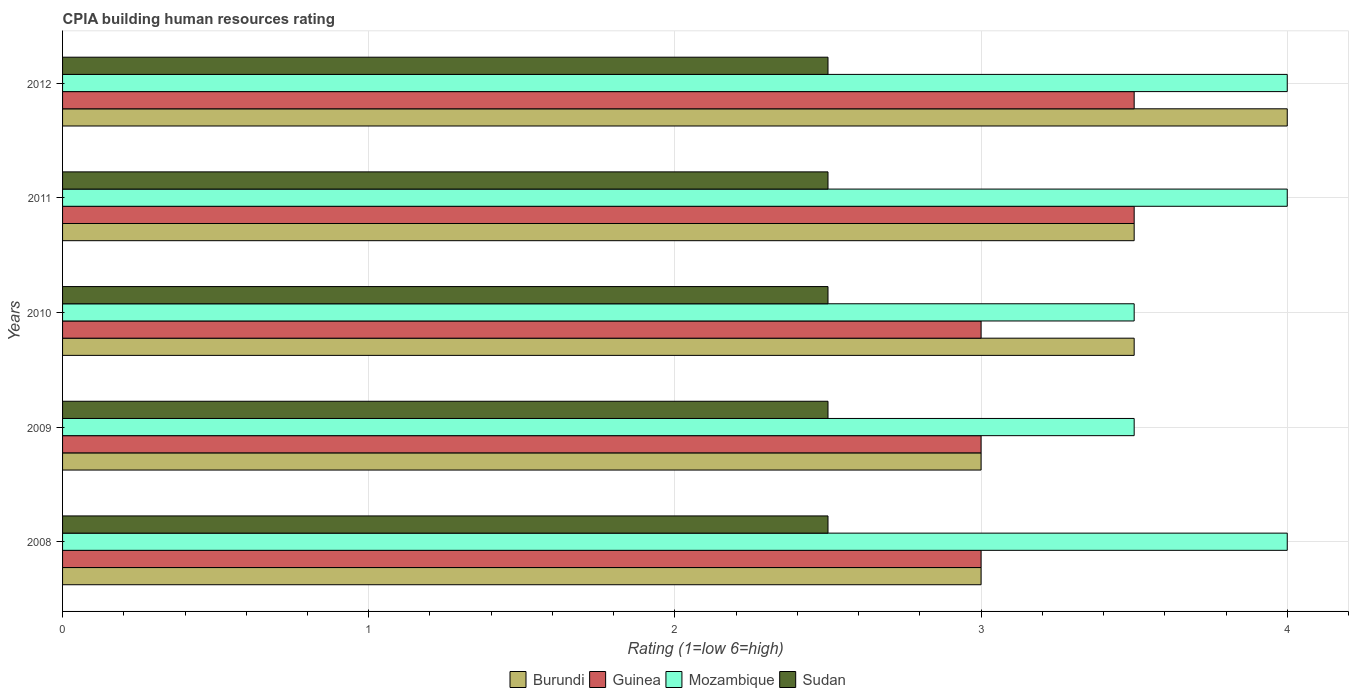Are the number of bars on each tick of the Y-axis equal?
Give a very brief answer. Yes. Across all years, what is the maximum CPIA rating in Guinea?
Offer a terse response. 3.5. What is the total CPIA rating in Sudan in the graph?
Give a very brief answer. 12.5. What is the difference between the CPIA rating in Sudan in 2011 and the CPIA rating in Guinea in 2012?
Offer a terse response. -1. In the year 2009, what is the difference between the CPIA rating in Sudan and CPIA rating in Guinea?
Your answer should be very brief. -0.5. In how many years, is the CPIA rating in Guinea greater than 2.4 ?
Your answer should be compact. 5. Is the difference between the CPIA rating in Sudan in 2008 and 2011 greater than the difference between the CPIA rating in Guinea in 2008 and 2011?
Ensure brevity in your answer.  Yes. What is the difference between the highest and the second highest CPIA rating in Guinea?
Give a very brief answer. 0. What is the difference between the highest and the lowest CPIA rating in Guinea?
Give a very brief answer. 0.5. What does the 4th bar from the top in 2010 represents?
Your answer should be compact. Burundi. What does the 3rd bar from the bottom in 2012 represents?
Provide a succinct answer. Mozambique. How many bars are there?
Keep it short and to the point. 20. Are all the bars in the graph horizontal?
Your answer should be very brief. Yes. What is the difference between two consecutive major ticks on the X-axis?
Provide a succinct answer. 1. Where does the legend appear in the graph?
Provide a short and direct response. Bottom center. How are the legend labels stacked?
Provide a succinct answer. Horizontal. What is the title of the graph?
Your answer should be compact. CPIA building human resources rating. Does "Croatia" appear as one of the legend labels in the graph?
Your response must be concise. No. What is the label or title of the X-axis?
Your response must be concise. Rating (1=low 6=high). What is the Rating (1=low 6=high) in Guinea in 2008?
Provide a short and direct response. 3. What is the Rating (1=low 6=high) in Sudan in 2008?
Your answer should be very brief. 2.5. What is the Rating (1=low 6=high) in Guinea in 2009?
Offer a terse response. 3. What is the Rating (1=low 6=high) of Mozambique in 2009?
Provide a succinct answer. 3.5. What is the Rating (1=low 6=high) of Guinea in 2010?
Your answer should be very brief. 3. What is the Rating (1=low 6=high) in Mozambique in 2010?
Make the answer very short. 3.5. What is the Rating (1=low 6=high) of Guinea in 2011?
Provide a succinct answer. 3.5. What is the Rating (1=low 6=high) in Mozambique in 2012?
Your answer should be very brief. 4. What is the Rating (1=low 6=high) of Sudan in 2012?
Your answer should be compact. 2.5. Across all years, what is the maximum Rating (1=low 6=high) of Burundi?
Keep it short and to the point. 4. Across all years, what is the minimum Rating (1=low 6=high) in Burundi?
Offer a very short reply. 3. Across all years, what is the minimum Rating (1=low 6=high) in Guinea?
Your response must be concise. 3. What is the total Rating (1=low 6=high) of Guinea in the graph?
Offer a very short reply. 16. What is the total Rating (1=low 6=high) of Sudan in the graph?
Provide a succinct answer. 12.5. What is the difference between the Rating (1=low 6=high) of Guinea in 2008 and that in 2009?
Make the answer very short. 0. What is the difference between the Rating (1=low 6=high) in Sudan in 2008 and that in 2009?
Offer a very short reply. 0. What is the difference between the Rating (1=low 6=high) in Burundi in 2008 and that in 2010?
Keep it short and to the point. -0.5. What is the difference between the Rating (1=low 6=high) of Mozambique in 2008 and that in 2010?
Offer a very short reply. 0.5. What is the difference between the Rating (1=low 6=high) in Guinea in 2008 and that in 2011?
Make the answer very short. -0.5. What is the difference between the Rating (1=low 6=high) of Mozambique in 2008 and that in 2011?
Provide a succinct answer. 0. What is the difference between the Rating (1=low 6=high) of Sudan in 2008 and that in 2011?
Give a very brief answer. 0. What is the difference between the Rating (1=low 6=high) in Burundi in 2008 and that in 2012?
Your response must be concise. -1. What is the difference between the Rating (1=low 6=high) of Guinea in 2008 and that in 2012?
Your response must be concise. -0.5. What is the difference between the Rating (1=low 6=high) in Sudan in 2008 and that in 2012?
Provide a short and direct response. 0. What is the difference between the Rating (1=low 6=high) of Mozambique in 2009 and that in 2010?
Keep it short and to the point. 0. What is the difference between the Rating (1=low 6=high) in Sudan in 2009 and that in 2010?
Provide a succinct answer. 0. What is the difference between the Rating (1=low 6=high) of Sudan in 2009 and that in 2011?
Give a very brief answer. 0. What is the difference between the Rating (1=low 6=high) in Guinea in 2009 and that in 2012?
Offer a very short reply. -0.5. What is the difference between the Rating (1=low 6=high) of Mozambique in 2009 and that in 2012?
Your answer should be very brief. -0.5. What is the difference between the Rating (1=low 6=high) in Sudan in 2009 and that in 2012?
Ensure brevity in your answer.  0. What is the difference between the Rating (1=low 6=high) in Guinea in 2010 and that in 2011?
Offer a terse response. -0.5. What is the difference between the Rating (1=low 6=high) in Mozambique in 2010 and that in 2011?
Make the answer very short. -0.5. What is the difference between the Rating (1=low 6=high) of Sudan in 2010 and that in 2011?
Ensure brevity in your answer.  0. What is the difference between the Rating (1=low 6=high) in Mozambique in 2010 and that in 2012?
Your answer should be compact. -0.5. What is the difference between the Rating (1=low 6=high) in Sudan in 2010 and that in 2012?
Make the answer very short. 0. What is the difference between the Rating (1=low 6=high) in Guinea in 2011 and that in 2012?
Ensure brevity in your answer.  0. What is the difference between the Rating (1=low 6=high) in Mozambique in 2011 and that in 2012?
Provide a succinct answer. 0. What is the difference between the Rating (1=low 6=high) in Sudan in 2011 and that in 2012?
Ensure brevity in your answer.  0. What is the difference between the Rating (1=low 6=high) of Burundi in 2008 and the Rating (1=low 6=high) of Mozambique in 2009?
Provide a short and direct response. -0.5. What is the difference between the Rating (1=low 6=high) of Guinea in 2008 and the Rating (1=low 6=high) of Mozambique in 2009?
Keep it short and to the point. -0.5. What is the difference between the Rating (1=low 6=high) in Burundi in 2008 and the Rating (1=low 6=high) in Guinea in 2010?
Provide a succinct answer. 0. What is the difference between the Rating (1=low 6=high) of Burundi in 2008 and the Rating (1=low 6=high) of Mozambique in 2010?
Offer a terse response. -0.5. What is the difference between the Rating (1=low 6=high) in Burundi in 2008 and the Rating (1=low 6=high) in Guinea in 2011?
Offer a very short reply. -0.5. What is the difference between the Rating (1=low 6=high) in Burundi in 2008 and the Rating (1=low 6=high) in Mozambique in 2011?
Ensure brevity in your answer.  -1. What is the difference between the Rating (1=low 6=high) in Guinea in 2008 and the Rating (1=low 6=high) in Mozambique in 2011?
Give a very brief answer. -1. What is the difference between the Rating (1=low 6=high) of Guinea in 2008 and the Rating (1=low 6=high) of Sudan in 2011?
Give a very brief answer. 0.5. What is the difference between the Rating (1=low 6=high) of Mozambique in 2008 and the Rating (1=low 6=high) of Sudan in 2011?
Your response must be concise. 1.5. What is the difference between the Rating (1=low 6=high) of Burundi in 2008 and the Rating (1=low 6=high) of Guinea in 2012?
Keep it short and to the point. -0.5. What is the difference between the Rating (1=low 6=high) in Burundi in 2008 and the Rating (1=low 6=high) in Sudan in 2012?
Your answer should be very brief. 0.5. What is the difference between the Rating (1=low 6=high) in Guinea in 2008 and the Rating (1=low 6=high) in Sudan in 2012?
Make the answer very short. 0.5. What is the difference between the Rating (1=low 6=high) of Burundi in 2009 and the Rating (1=low 6=high) of Guinea in 2010?
Your answer should be compact. 0. What is the difference between the Rating (1=low 6=high) in Burundi in 2009 and the Rating (1=low 6=high) in Mozambique in 2010?
Your answer should be very brief. -0.5. What is the difference between the Rating (1=low 6=high) in Burundi in 2009 and the Rating (1=low 6=high) in Sudan in 2010?
Offer a terse response. 0.5. What is the difference between the Rating (1=low 6=high) of Guinea in 2009 and the Rating (1=low 6=high) of Sudan in 2010?
Your answer should be compact. 0.5. What is the difference between the Rating (1=low 6=high) in Mozambique in 2009 and the Rating (1=low 6=high) in Sudan in 2010?
Provide a short and direct response. 1. What is the difference between the Rating (1=low 6=high) of Burundi in 2009 and the Rating (1=low 6=high) of Sudan in 2011?
Your answer should be compact. 0.5. What is the difference between the Rating (1=low 6=high) in Guinea in 2009 and the Rating (1=low 6=high) in Sudan in 2011?
Provide a succinct answer. 0.5. What is the difference between the Rating (1=low 6=high) in Burundi in 2009 and the Rating (1=low 6=high) in Guinea in 2012?
Offer a terse response. -0.5. What is the difference between the Rating (1=low 6=high) of Guinea in 2009 and the Rating (1=low 6=high) of Mozambique in 2012?
Give a very brief answer. -1. What is the difference between the Rating (1=low 6=high) in Guinea in 2009 and the Rating (1=low 6=high) in Sudan in 2012?
Keep it short and to the point. 0.5. What is the difference between the Rating (1=low 6=high) in Mozambique in 2009 and the Rating (1=low 6=high) in Sudan in 2012?
Ensure brevity in your answer.  1. What is the difference between the Rating (1=low 6=high) of Burundi in 2010 and the Rating (1=low 6=high) of Guinea in 2011?
Your answer should be very brief. 0. What is the difference between the Rating (1=low 6=high) of Burundi in 2010 and the Rating (1=low 6=high) of Mozambique in 2011?
Provide a succinct answer. -0.5. What is the difference between the Rating (1=low 6=high) in Burundi in 2010 and the Rating (1=low 6=high) in Sudan in 2011?
Offer a terse response. 1. What is the difference between the Rating (1=low 6=high) of Burundi in 2010 and the Rating (1=low 6=high) of Mozambique in 2012?
Your response must be concise. -0.5. What is the difference between the Rating (1=low 6=high) in Burundi in 2010 and the Rating (1=low 6=high) in Sudan in 2012?
Provide a succinct answer. 1. What is the difference between the Rating (1=low 6=high) in Guinea in 2010 and the Rating (1=low 6=high) in Mozambique in 2012?
Provide a short and direct response. -1. What is the difference between the Rating (1=low 6=high) in Burundi in 2011 and the Rating (1=low 6=high) in Guinea in 2012?
Ensure brevity in your answer.  0. What is the difference between the Rating (1=low 6=high) in Burundi in 2011 and the Rating (1=low 6=high) in Mozambique in 2012?
Offer a terse response. -0.5. What is the difference between the Rating (1=low 6=high) in Guinea in 2011 and the Rating (1=low 6=high) in Mozambique in 2012?
Give a very brief answer. -0.5. What is the difference between the Rating (1=low 6=high) of Guinea in 2011 and the Rating (1=low 6=high) of Sudan in 2012?
Keep it short and to the point. 1. What is the average Rating (1=low 6=high) of Sudan per year?
Provide a short and direct response. 2.5. In the year 2008, what is the difference between the Rating (1=low 6=high) in Burundi and Rating (1=low 6=high) in Guinea?
Your response must be concise. 0. In the year 2008, what is the difference between the Rating (1=low 6=high) of Burundi and Rating (1=low 6=high) of Mozambique?
Provide a succinct answer. -1. In the year 2008, what is the difference between the Rating (1=low 6=high) of Guinea and Rating (1=low 6=high) of Mozambique?
Make the answer very short. -1. In the year 2009, what is the difference between the Rating (1=low 6=high) in Burundi and Rating (1=low 6=high) in Mozambique?
Offer a terse response. -0.5. In the year 2009, what is the difference between the Rating (1=low 6=high) of Burundi and Rating (1=low 6=high) of Sudan?
Offer a terse response. 0.5. In the year 2009, what is the difference between the Rating (1=low 6=high) of Mozambique and Rating (1=low 6=high) of Sudan?
Your answer should be compact. 1. In the year 2010, what is the difference between the Rating (1=low 6=high) of Burundi and Rating (1=low 6=high) of Guinea?
Your response must be concise. 0.5. In the year 2010, what is the difference between the Rating (1=low 6=high) of Burundi and Rating (1=low 6=high) of Mozambique?
Your response must be concise. 0. In the year 2010, what is the difference between the Rating (1=low 6=high) in Burundi and Rating (1=low 6=high) in Sudan?
Keep it short and to the point. 1. In the year 2010, what is the difference between the Rating (1=low 6=high) in Mozambique and Rating (1=low 6=high) in Sudan?
Ensure brevity in your answer.  1. In the year 2011, what is the difference between the Rating (1=low 6=high) in Burundi and Rating (1=low 6=high) in Guinea?
Give a very brief answer. 0. In the year 2011, what is the difference between the Rating (1=low 6=high) in Burundi and Rating (1=low 6=high) in Sudan?
Give a very brief answer. 1. In the year 2011, what is the difference between the Rating (1=low 6=high) of Guinea and Rating (1=low 6=high) of Mozambique?
Offer a very short reply. -0.5. In the year 2011, what is the difference between the Rating (1=low 6=high) of Guinea and Rating (1=low 6=high) of Sudan?
Keep it short and to the point. 1. In the year 2012, what is the difference between the Rating (1=low 6=high) in Burundi and Rating (1=low 6=high) in Guinea?
Your answer should be compact. 0.5. In the year 2012, what is the difference between the Rating (1=low 6=high) in Burundi and Rating (1=low 6=high) in Mozambique?
Your answer should be very brief. 0. In the year 2012, what is the difference between the Rating (1=low 6=high) in Guinea and Rating (1=low 6=high) in Sudan?
Your answer should be compact. 1. In the year 2012, what is the difference between the Rating (1=low 6=high) of Mozambique and Rating (1=low 6=high) of Sudan?
Your answer should be very brief. 1.5. What is the ratio of the Rating (1=low 6=high) of Burundi in 2008 to that in 2009?
Your answer should be compact. 1. What is the ratio of the Rating (1=low 6=high) in Mozambique in 2008 to that in 2010?
Offer a very short reply. 1.14. What is the ratio of the Rating (1=low 6=high) in Burundi in 2008 to that in 2011?
Your answer should be very brief. 0.86. What is the ratio of the Rating (1=low 6=high) in Mozambique in 2008 to that in 2011?
Provide a succinct answer. 1. What is the ratio of the Rating (1=low 6=high) of Sudan in 2008 to that in 2011?
Provide a short and direct response. 1. What is the ratio of the Rating (1=low 6=high) of Guinea in 2009 to that in 2010?
Keep it short and to the point. 1. What is the ratio of the Rating (1=low 6=high) of Sudan in 2009 to that in 2010?
Make the answer very short. 1. What is the ratio of the Rating (1=low 6=high) of Guinea in 2009 to that in 2011?
Your answer should be very brief. 0.86. What is the ratio of the Rating (1=low 6=high) of Mozambique in 2009 to that in 2011?
Provide a short and direct response. 0.88. What is the ratio of the Rating (1=low 6=high) of Burundi in 2009 to that in 2012?
Offer a very short reply. 0.75. What is the ratio of the Rating (1=low 6=high) of Sudan in 2009 to that in 2012?
Provide a succinct answer. 1. What is the ratio of the Rating (1=low 6=high) of Guinea in 2010 to that in 2011?
Your response must be concise. 0.86. What is the ratio of the Rating (1=low 6=high) in Sudan in 2010 to that in 2011?
Give a very brief answer. 1. What is the ratio of the Rating (1=low 6=high) in Burundi in 2010 to that in 2012?
Keep it short and to the point. 0.88. What is the ratio of the Rating (1=low 6=high) of Mozambique in 2010 to that in 2012?
Make the answer very short. 0.88. What is the ratio of the Rating (1=low 6=high) in Sudan in 2011 to that in 2012?
Your answer should be very brief. 1. What is the difference between the highest and the second highest Rating (1=low 6=high) in Burundi?
Provide a short and direct response. 0.5. What is the difference between the highest and the second highest Rating (1=low 6=high) of Mozambique?
Offer a very short reply. 0. What is the difference between the highest and the lowest Rating (1=low 6=high) of Guinea?
Provide a short and direct response. 0.5. 